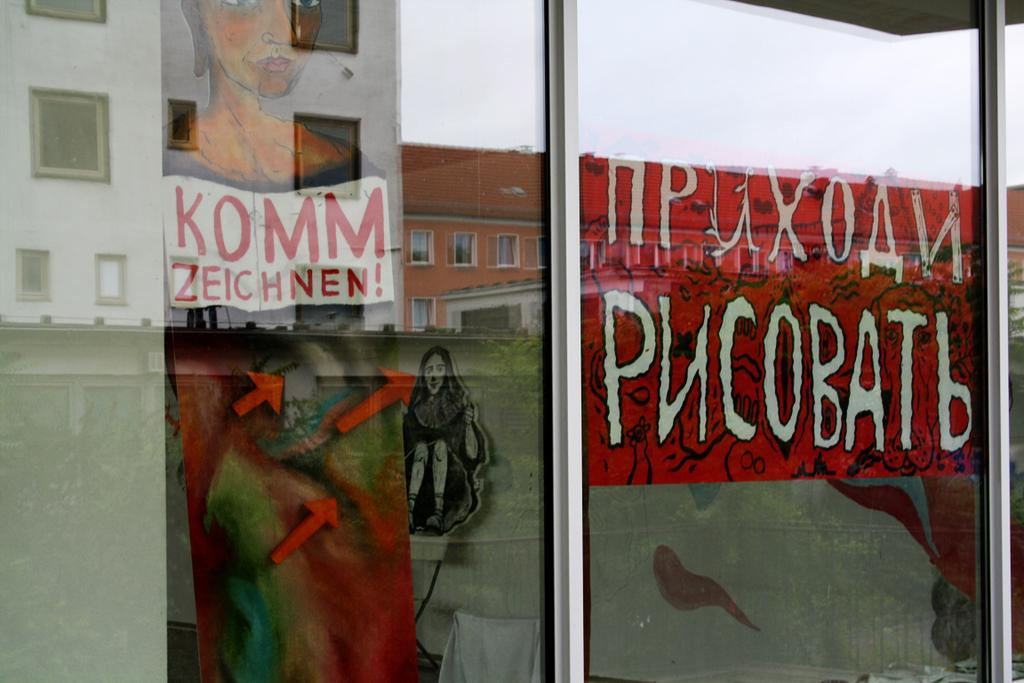What type of doors can be seen in the image? There are glass doors in the image. What is hanging on the walls in the image? There are paintings in the image. Is there any text visible in the image? Yes, there is some text in the image. What can be seen through the glass doors? Buildings are visible through the glass doors. Can you see any coastlines or beaches through the glass doors? There is no mention of a coast or beach in the image, and the focus is on the glass doors and buildings visible through them. Are there any apples in the image? There is no mention of apples in the image; the focus is on the glass doors, paintings, text, and buildings. 